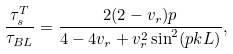<formula> <loc_0><loc_0><loc_500><loc_500>\frac { \tau _ { s } ^ { T } } { \tau _ { B L } } = \frac { 2 ( 2 - v _ { r } ) p } { 4 - 4 v _ { r } + v _ { r } ^ { 2 } \sin ^ { 2 } ( p k L ) } ,</formula> 